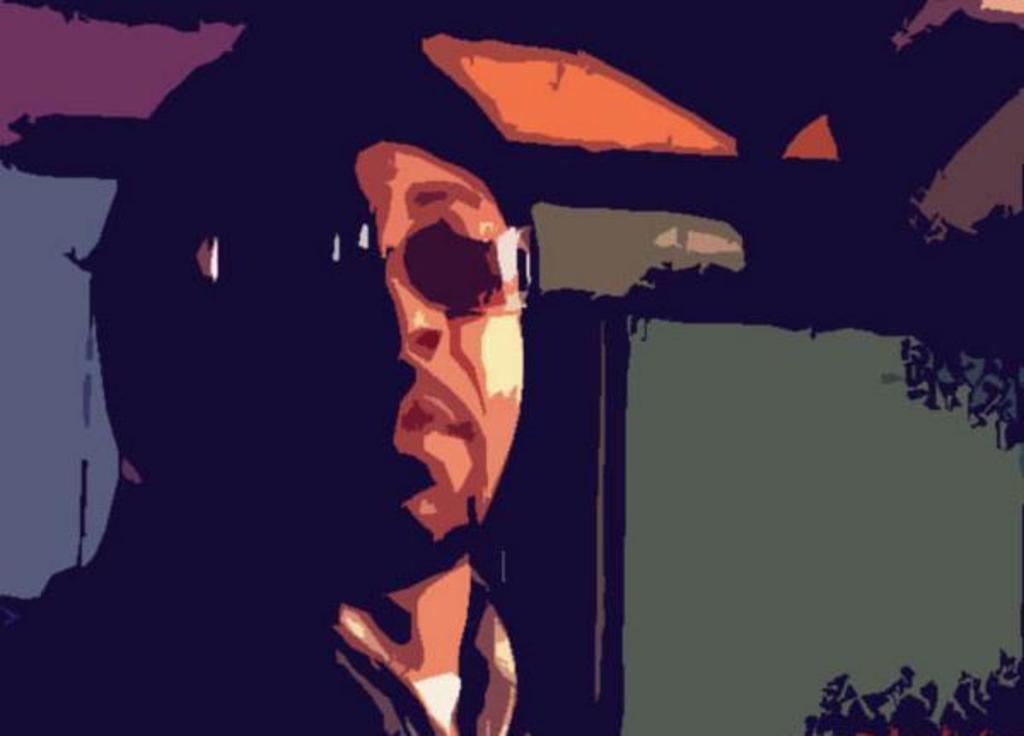Describe this image in one or two sentences. In the picture I can see a man on the left side of the image and looks like there is spectacles on his eyes. 